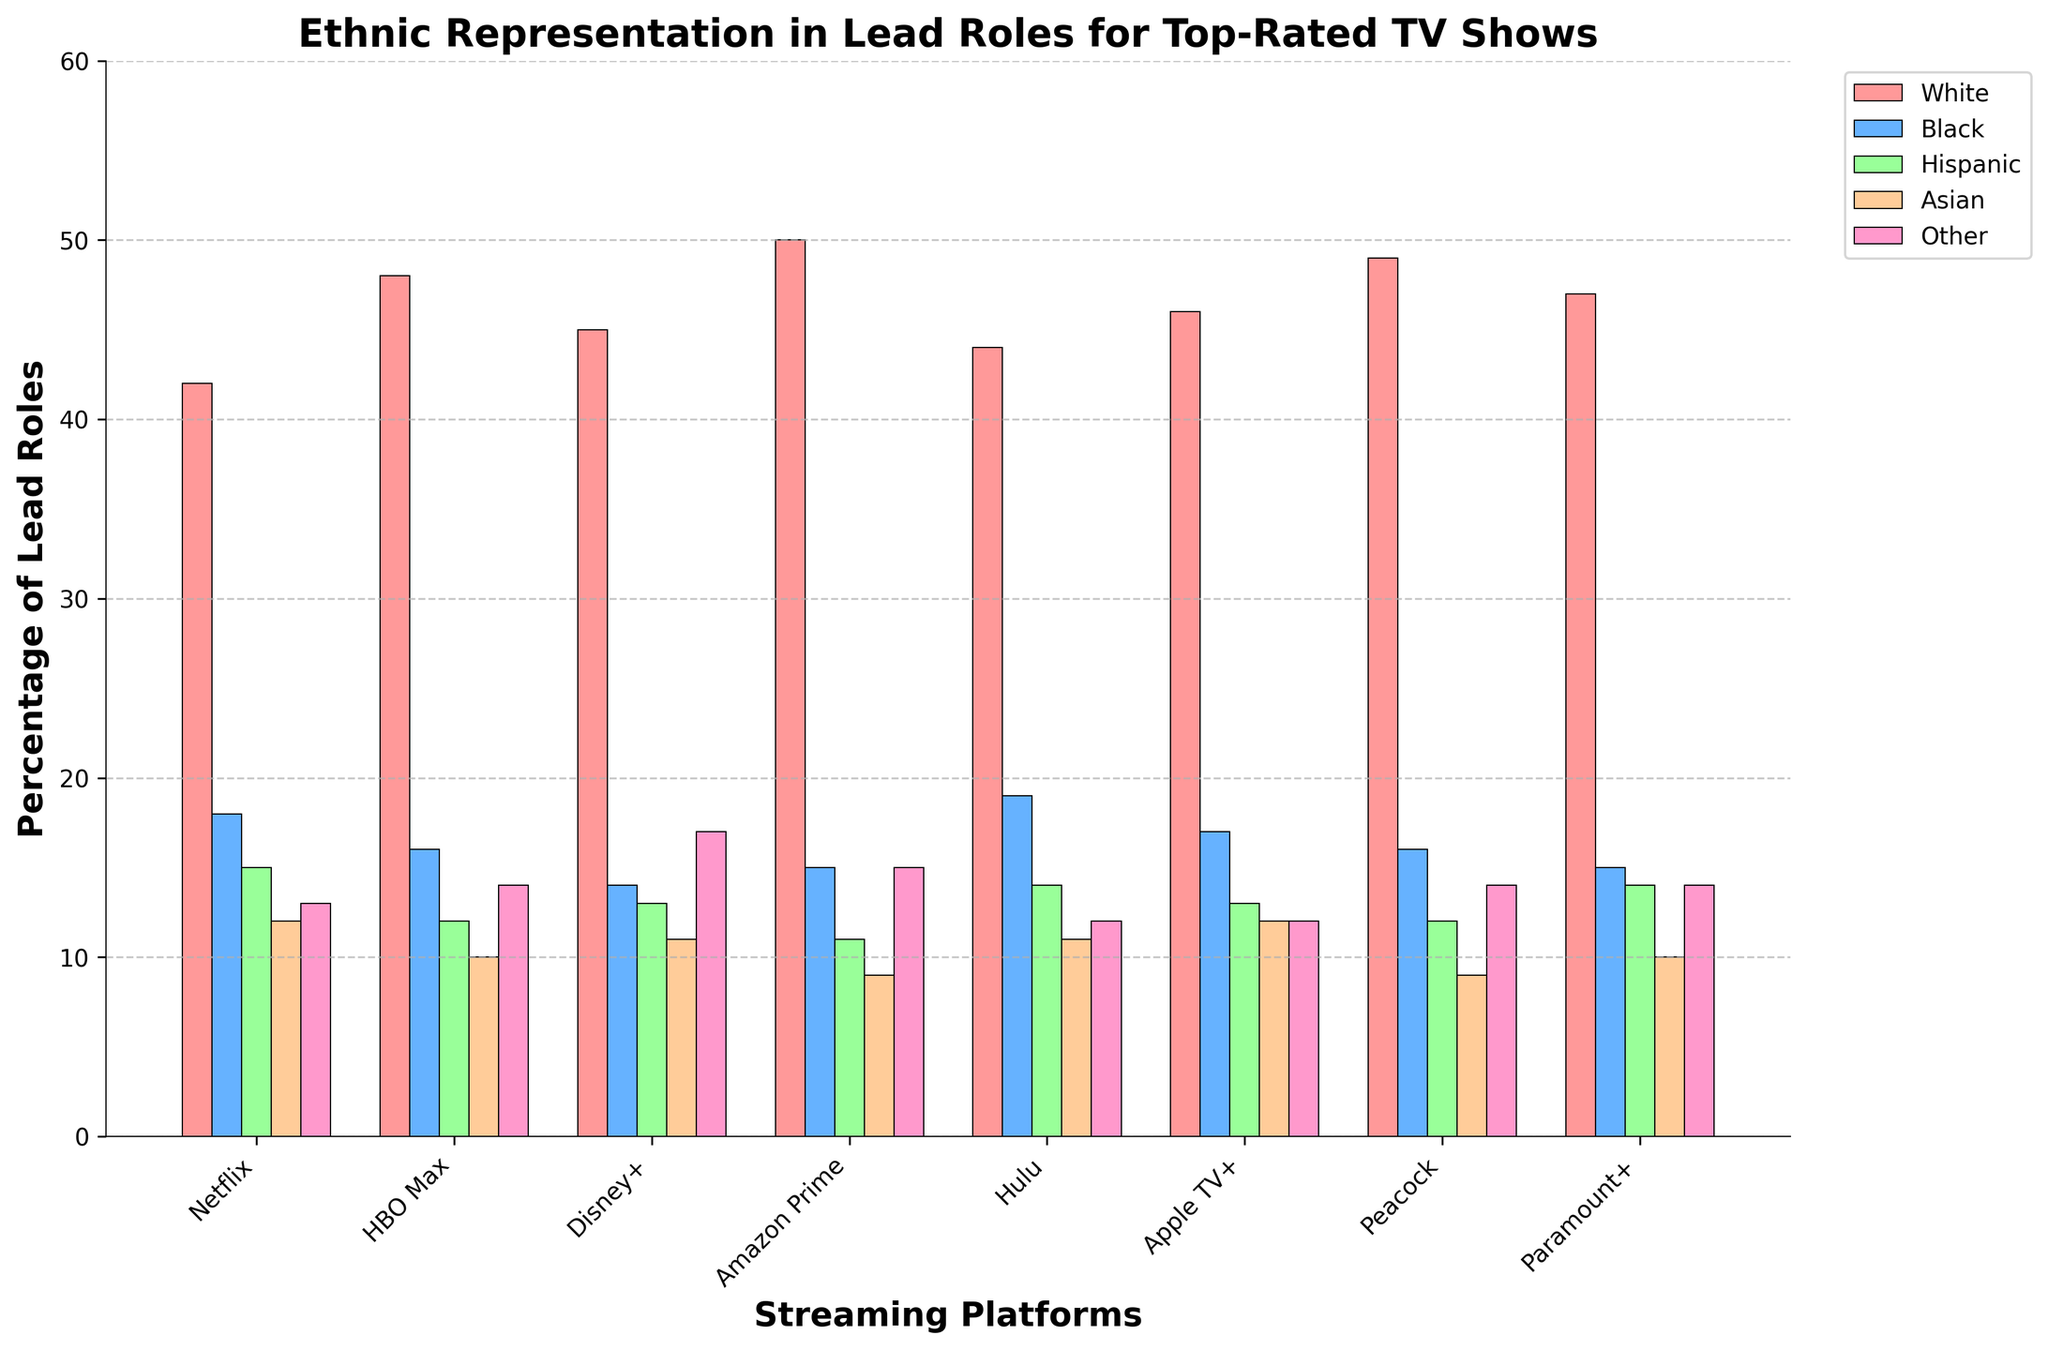Which streaming platform has the highest representation for White lead roles? To find the streaming platform with the highest representation for White lead roles, look at the tallest bar in the "White" category across all platforms. The tallest bar here is for Amazon Prime with a value of 50.
Answer: Amazon Prime Which streaming platform has the lowest representation for Asian lead roles? To determine the streaming platform with the lowest representation for Asian lead roles, compare the heights of the bars corresponding to "Asian" across all platforms. The shortest bar is for Amazon Prime and Peacock, both with a value of 9.
Answer: Amazon Prime, Peacock What is the sum of percentages of Black lead roles across all streaming platforms? To find the sum, add the percentages of Black lead roles from all platforms: 18 (Netflix) + 16 (HBO Max) + 14 (Disney+) + 15 (Amazon Prime) + 19 (Hulu) + 17 (Apple TV+) + 16 (Peacock) + 15 (Paramount+) which equals 130.
Answer: 130 Which two ethnicities combined account for a higher percentage of lead roles on Netflix compared to White lead roles on the same platform? Combine the percentages of the other ethnicities on Netflix and compare those sums to the percentage for White roles. Adding Black (18) and Hispanic (15) gets 33, which is less than 42, so add Asian (12) getting 45, which is greater than 42.
Answer: Black and Hispanic How many streaming platforms have a higher representation of Other lead roles than Black lead roles? Count the number of platforms where the bar for "Other" is taller than the bar for "Black." This applies to Netflix (13 > 18), HBO Max (14 > 16), Disney+ (17 > 14), Apple TV+ (12 > 17), and Peacock (14 > 16). Five have a higher representation of Other lead roles than Black.
Answer: 5 What is the average representation of Hispanic lead roles across all streaming platforms? Average is calculated by summing the Hispanic lead roles percentages and dividing by the number of platforms: (15 + 12 + 13 + 11 + 14 + 13 + 12 + 14)/8 = 13.
Answer: 13 Which ethnic group shows the least variation in its representation across all streaming platforms? To determine the least variation, visually compare the consistency of bar heights across different platforms for each ethnic group. The group "Other" appears to have the most consistent representation with values close to 14 or 13 for most platforms.
Answer: Other 